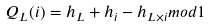Convert formula to latex. <formula><loc_0><loc_0><loc_500><loc_500>Q _ { L } ( i ) = h _ { L } + h _ { i } - h _ { L \times i } m o d 1</formula> 